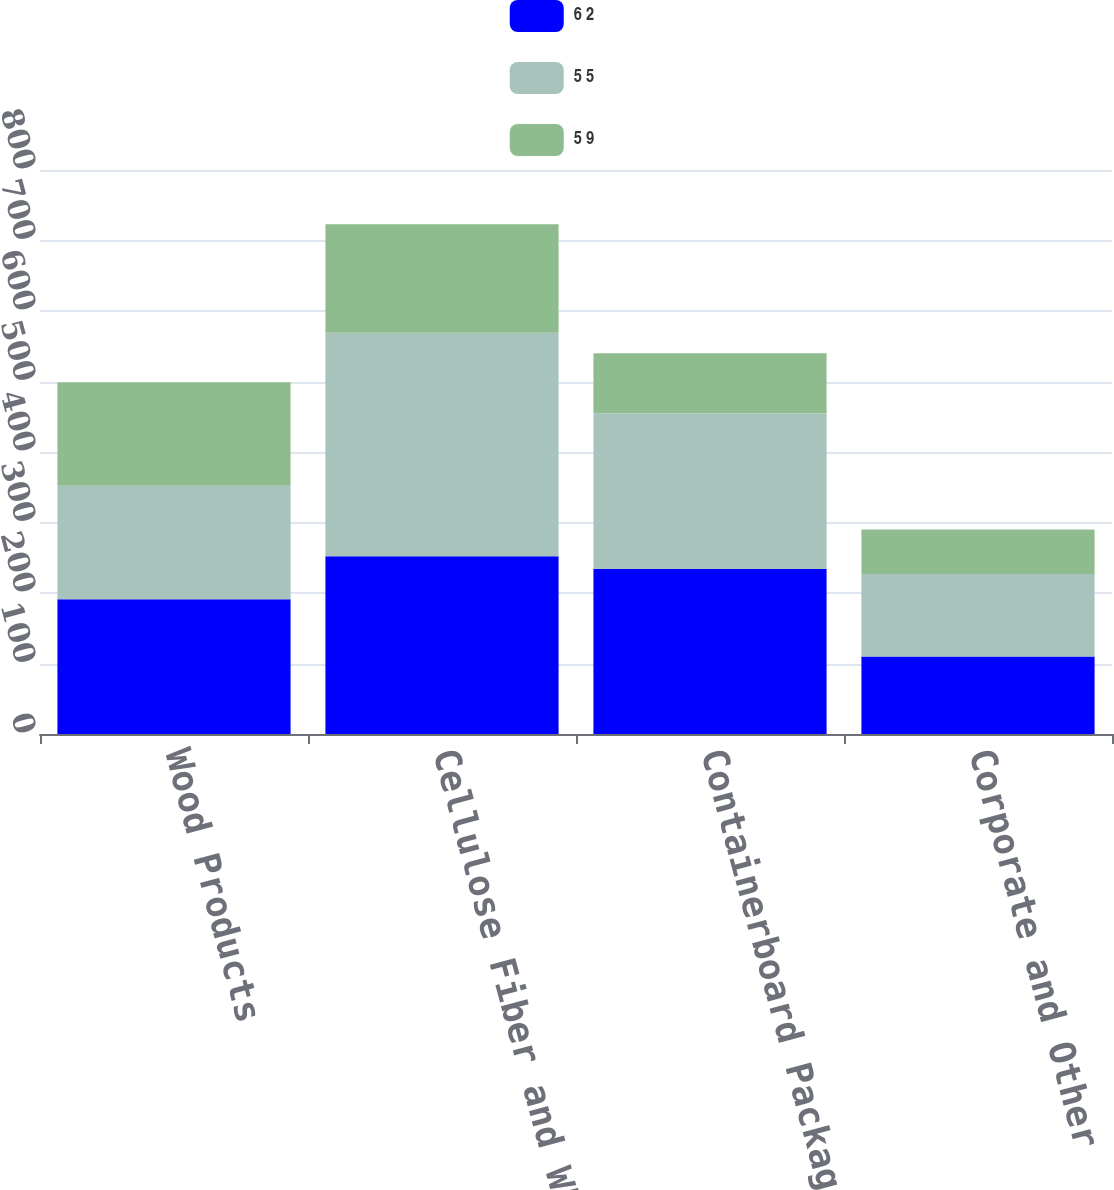Convert chart. <chart><loc_0><loc_0><loc_500><loc_500><stacked_bar_chart><ecel><fcel>Wood Products<fcel>Cellulose Fiber and White<fcel>Containerboard Packaging and<fcel>Corporate and Other<nl><fcel>6 2<fcel>191<fcel>252<fcel>234<fcel>110<nl><fcel>5 5<fcel>161<fcel>317<fcel>221<fcel>117<nl><fcel>5 9<fcel>147<fcel>154<fcel>85<fcel>63<nl></chart> 